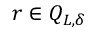Convert formula to latex. <formula><loc_0><loc_0><loc_500><loc_500>r \in Q _ { L , \delta }</formula> 